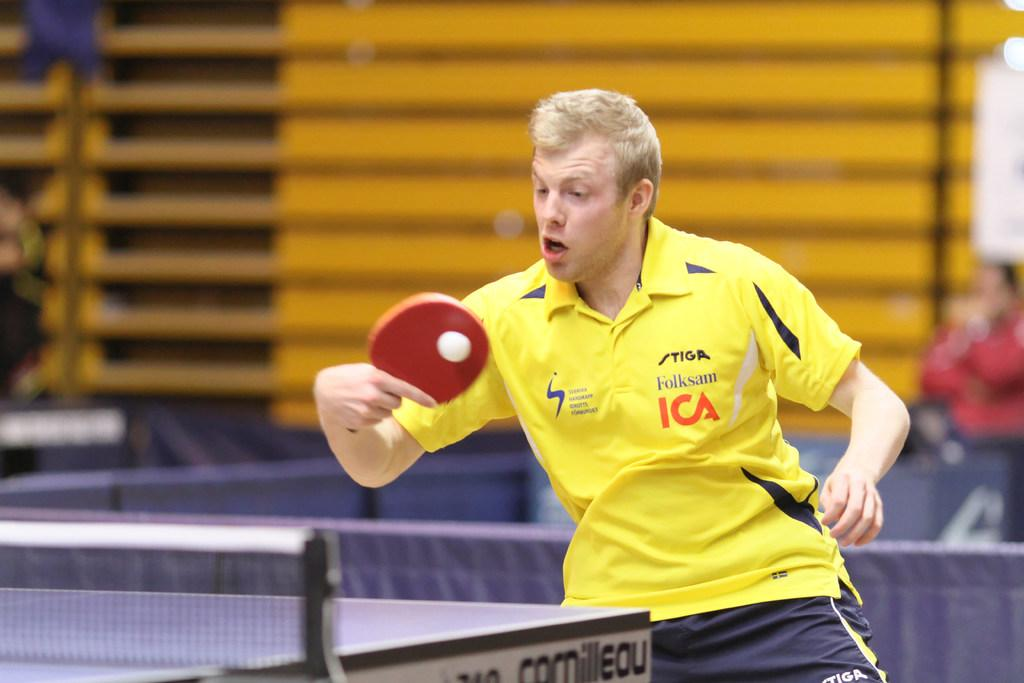Provide a one-sentence caption for the provided image. A male playing pingpong in a yellow Folksam ICA polo shirt. 